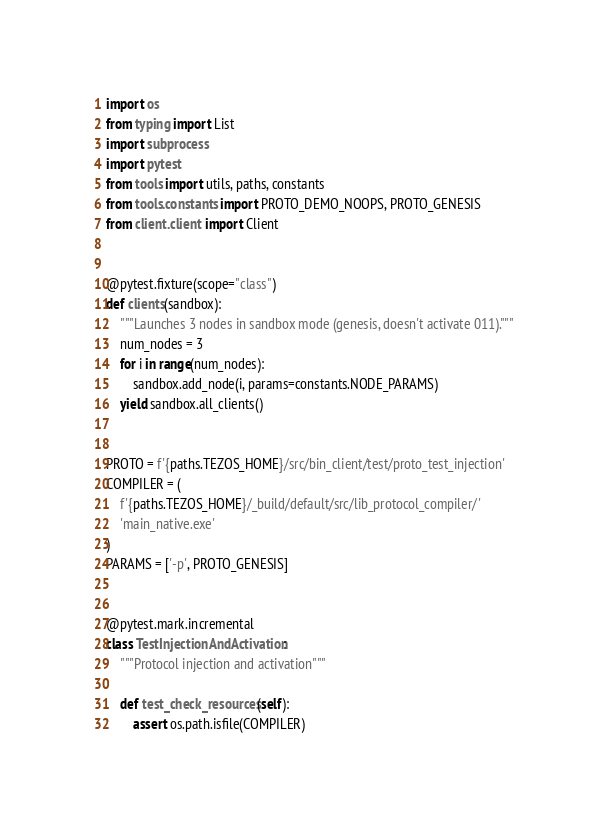Convert code to text. <code><loc_0><loc_0><loc_500><loc_500><_Python_>import os
from typing import List
import subprocess
import pytest
from tools import utils, paths, constants
from tools.constants import PROTO_DEMO_NOOPS, PROTO_GENESIS
from client.client import Client


@pytest.fixture(scope="class")
def clients(sandbox):
    """Launches 3 nodes in sandbox mode (genesis, doesn't activate 011)."""
    num_nodes = 3
    for i in range(num_nodes):
        sandbox.add_node(i, params=constants.NODE_PARAMS)
    yield sandbox.all_clients()


PROTO = f'{paths.TEZOS_HOME}/src/bin_client/test/proto_test_injection'
COMPILER = (
    f'{paths.TEZOS_HOME}/_build/default/src/lib_protocol_compiler/'
    'main_native.exe'
)
PARAMS = ['-p', PROTO_GENESIS]


@pytest.mark.incremental
class TestInjectionAndActivation:
    """Protocol injection and activation"""

    def test_check_resources(self):
        assert os.path.isfile(COMPILER)</code> 